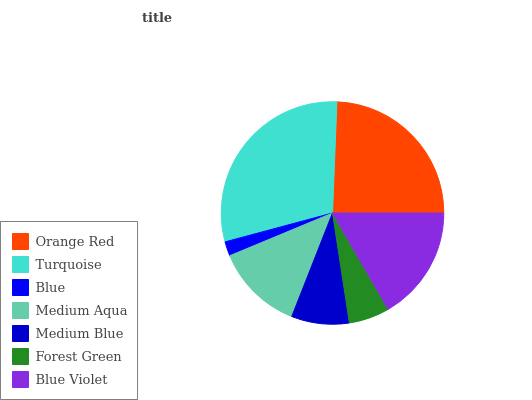Is Blue the minimum?
Answer yes or no. Yes. Is Turquoise the maximum?
Answer yes or no. Yes. Is Turquoise the minimum?
Answer yes or no. No. Is Blue the maximum?
Answer yes or no. No. Is Turquoise greater than Blue?
Answer yes or no. Yes. Is Blue less than Turquoise?
Answer yes or no. Yes. Is Blue greater than Turquoise?
Answer yes or no. No. Is Turquoise less than Blue?
Answer yes or no. No. Is Medium Aqua the high median?
Answer yes or no. Yes. Is Medium Aqua the low median?
Answer yes or no. Yes. Is Turquoise the high median?
Answer yes or no. No. Is Blue the low median?
Answer yes or no. No. 